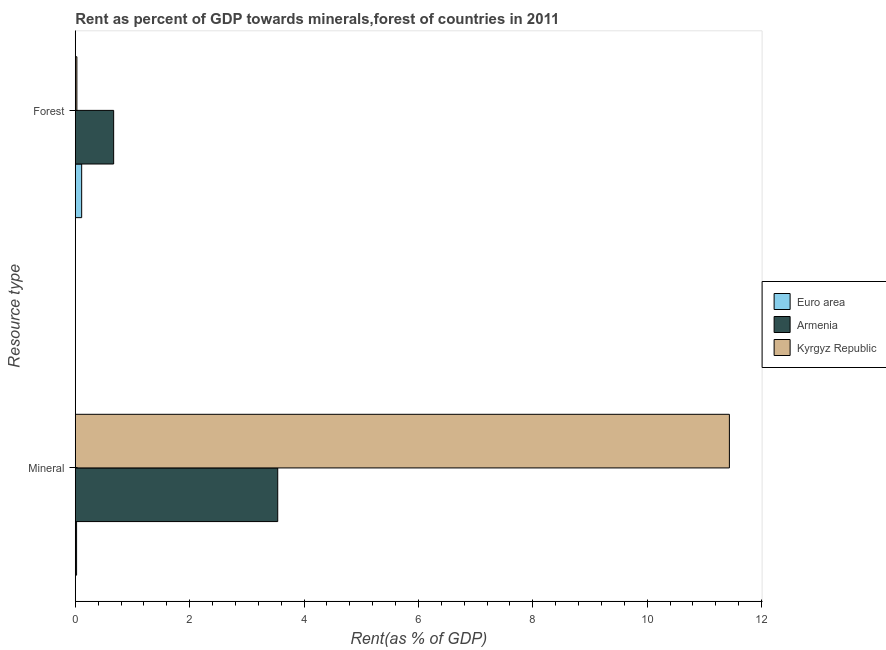How many groups of bars are there?
Your response must be concise. 2. Are the number of bars per tick equal to the number of legend labels?
Keep it short and to the point. Yes. Are the number of bars on each tick of the Y-axis equal?
Make the answer very short. Yes. How many bars are there on the 2nd tick from the bottom?
Your response must be concise. 3. What is the label of the 2nd group of bars from the top?
Make the answer very short. Mineral. What is the forest rent in Kyrgyz Republic?
Give a very brief answer. 0.03. Across all countries, what is the maximum forest rent?
Make the answer very short. 0.67. Across all countries, what is the minimum forest rent?
Your response must be concise. 0.03. In which country was the mineral rent maximum?
Make the answer very short. Kyrgyz Republic. In which country was the forest rent minimum?
Provide a short and direct response. Kyrgyz Republic. What is the total mineral rent in the graph?
Give a very brief answer. 15. What is the difference between the mineral rent in Armenia and that in Euro area?
Offer a terse response. 3.52. What is the difference between the forest rent in Euro area and the mineral rent in Armenia?
Offer a very short reply. -3.43. What is the average mineral rent per country?
Offer a very short reply. 5. What is the difference between the mineral rent and forest rent in Euro area?
Ensure brevity in your answer.  -0.09. In how many countries, is the mineral rent greater than 6 %?
Keep it short and to the point. 1. What is the ratio of the forest rent in Armenia to that in Kyrgyz Republic?
Your answer should be compact. 24.44. What does the 1st bar from the top in Forest represents?
Provide a short and direct response. Kyrgyz Republic. What does the 1st bar from the bottom in Forest represents?
Give a very brief answer. Euro area. Are all the bars in the graph horizontal?
Your response must be concise. Yes. What is the difference between two consecutive major ticks on the X-axis?
Offer a terse response. 2. Are the values on the major ticks of X-axis written in scientific E-notation?
Provide a short and direct response. No. Does the graph contain grids?
Your response must be concise. No. Where does the legend appear in the graph?
Give a very brief answer. Center right. How many legend labels are there?
Keep it short and to the point. 3. What is the title of the graph?
Give a very brief answer. Rent as percent of GDP towards minerals,forest of countries in 2011. Does "Sweden" appear as one of the legend labels in the graph?
Your answer should be compact. No. What is the label or title of the X-axis?
Your answer should be compact. Rent(as % of GDP). What is the label or title of the Y-axis?
Your response must be concise. Resource type. What is the Rent(as % of GDP) in Euro area in Mineral?
Ensure brevity in your answer.  0.02. What is the Rent(as % of GDP) of Armenia in Mineral?
Provide a short and direct response. 3.54. What is the Rent(as % of GDP) in Kyrgyz Republic in Mineral?
Your answer should be compact. 11.44. What is the Rent(as % of GDP) of Euro area in Forest?
Your response must be concise. 0.11. What is the Rent(as % of GDP) of Armenia in Forest?
Offer a very short reply. 0.67. What is the Rent(as % of GDP) of Kyrgyz Republic in Forest?
Offer a terse response. 0.03. Across all Resource type, what is the maximum Rent(as % of GDP) in Euro area?
Make the answer very short. 0.11. Across all Resource type, what is the maximum Rent(as % of GDP) of Armenia?
Offer a very short reply. 3.54. Across all Resource type, what is the maximum Rent(as % of GDP) of Kyrgyz Republic?
Make the answer very short. 11.44. Across all Resource type, what is the minimum Rent(as % of GDP) in Euro area?
Your answer should be compact. 0.02. Across all Resource type, what is the minimum Rent(as % of GDP) of Armenia?
Ensure brevity in your answer.  0.67. Across all Resource type, what is the minimum Rent(as % of GDP) of Kyrgyz Republic?
Your answer should be very brief. 0.03. What is the total Rent(as % of GDP) in Euro area in the graph?
Provide a short and direct response. 0.13. What is the total Rent(as % of GDP) of Armenia in the graph?
Give a very brief answer. 4.21. What is the total Rent(as % of GDP) in Kyrgyz Republic in the graph?
Your answer should be very brief. 11.47. What is the difference between the Rent(as % of GDP) of Euro area in Mineral and that in Forest?
Keep it short and to the point. -0.09. What is the difference between the Rent(as % of GDP) in Armenia in Mineral and that in Forest?
Offer a terse response. 2.87. What is the difference between the Rent(as % of GDP) of Kyrgyz Republic in Mineral and that in Forest?
Offer a terse response. 11.41. What is the difference between the Rent(as % of GDP) of Euro area in Mineral and the Rent(as % of GDP) of Armenia in Forest?
Ensure brevity in your answer.  -0.65. What is the difference between the Rent(as % of GDP) of Euro area in Mineral and the Rent(as % of GDP) of Kyrgyz Republic in Forest?
Keep it short and to the point. -0.01. What is the difference between the Rent(as % of GDP) of Armenia in Mineral and the Rent(as % of GDP) of Kyrgyz Republic in Forest?
Offer a very short reply. 3.51. What is the average Rent(as % of GDP) of Euro area per Resource type?
Your response must be concise. 0.07. What is the average Rent(as % of GDP) in Armenia per Resource type?
Give a very brief answer. 2.11. What is the average Rent(as % of GDP) in Kyrgyz Republic per Resource type?
Your answer should be very brief. 5.73. What is the difference between the Rent(as % of GDP) of Euro area and Rent(as % of GDP) of Armenia in Mineral?
Your answer should be compact. -3.52. What is the difference between the Rent(as % of GDP) of Euro area and Rent(as % of GDP) of Kyrgyz Republic in Mineral?
Make the answer very short. -11.42. What is the difference between the Rent(as % of GDP) in Armenia and Rent(as % of GDP) in Kyrgyz Republic in Mineral?
Offer a terse response. -7.9. What is the difference between the Rent(as % of GDP) in Euro area and Rent(as % of GDP) in Armenia in Forest?
Offer a terse response. -0.56. What is the difference between the Rent(as % of GDP) in Euro area and Rent(as % of GDP) in Kyrgyz Republic in Forest?
Offer a terse response. 0.08. What is the difference between the Rent(as % of GDP) in Armenia and Rent(as % of GDP) in Kyrgyz Republic in Forest?
Your answer should be very brief. 0.64. What is the ratio of the Rent(as % of GDP) of Euro area in Mineral to that in Forest?
Your answer should be compact. 0.2. What is the ratio of the Rent(as % of GDP) of Armenia in Mineral to that in Forest?
Your answer should be compact. 5.28. What is the ratio of the Rent(as % of GDP) in Kyrgyz Republic in Mineral to that in Forest?
Provide a succinct answer. 416.81. What is the difference between the highest and the second highest Rent(as % of GDP) in Euro area?
Provide a short and direct response. 0.09. What is the difference between the highest and the second highest Rent(as % of GDP) of Armenia?
Give a very brief answer. 2.87. What is the difference between the highest and the second highest Rent(as % of GDP) of Kyrgyz Republic?
Provide a succinct answer. 11.41. What is the difference between the highest and the lowest Rent(as % of GDP) of Euro area?
Offer a terse response. 0.09. What is the difference between the highest and the lowest Rent(as % of GDP) in Armenia?
Give a very brief answer. 2.87. What is the difference between the highest and the lowest Rent(as % of GDP) of Kyrgyz Republic?
Provide a succinct answer. 11.41. 